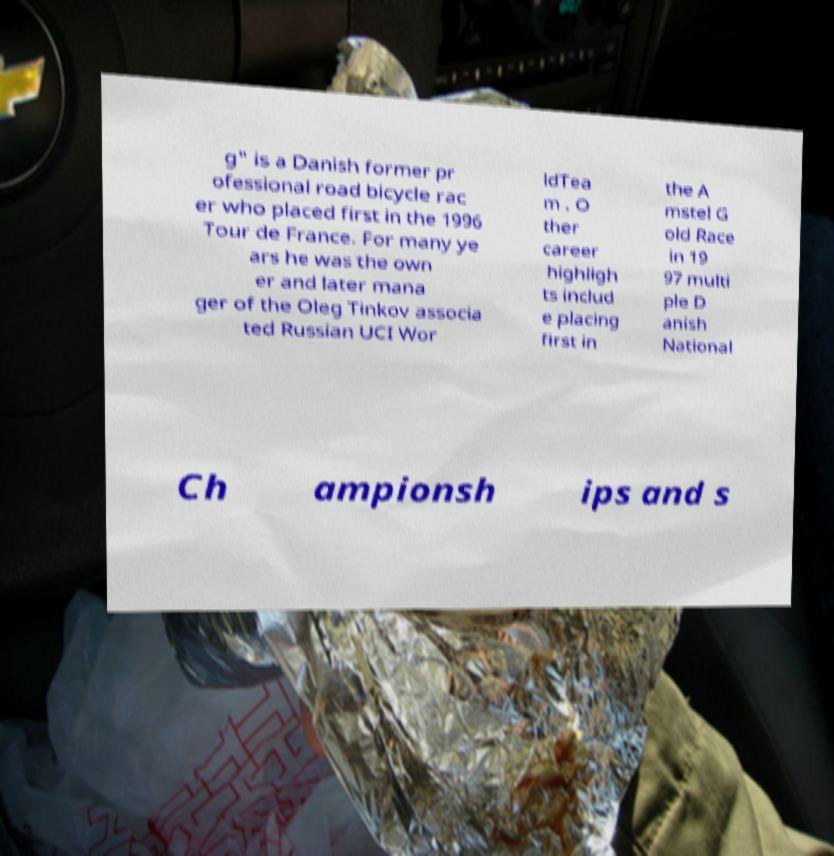Can you read and provide the text displayed in the image?This photo seems to have some interesting text. Can you extract and type it out for me? g" is a Danish former pr ofessional road bicycle rac er who placed first in the 1996 Tour de France. For many ye ars he was the own er and later mana ger of the Oleg Tinkov associa ted Russian UCI Wor ldTea m . O ther career highligh ts includ e placing first in the A mstel G old Race in 19 97 multi ple D anish National Ch ampionsh ips and s 